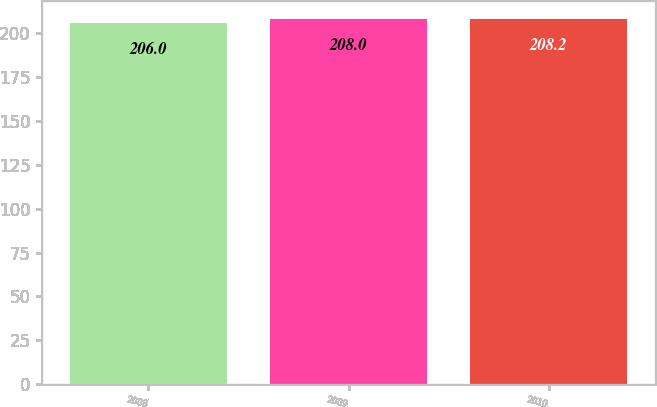Convert chart to OTSL. <chart><loc_0><loc_0><loc_500><loc_500><bar_chart><fcel>2008<fcel>2009<fcel>2010<nl><fcel>206<fcel>208<fcel>208.2<nl></chart> 